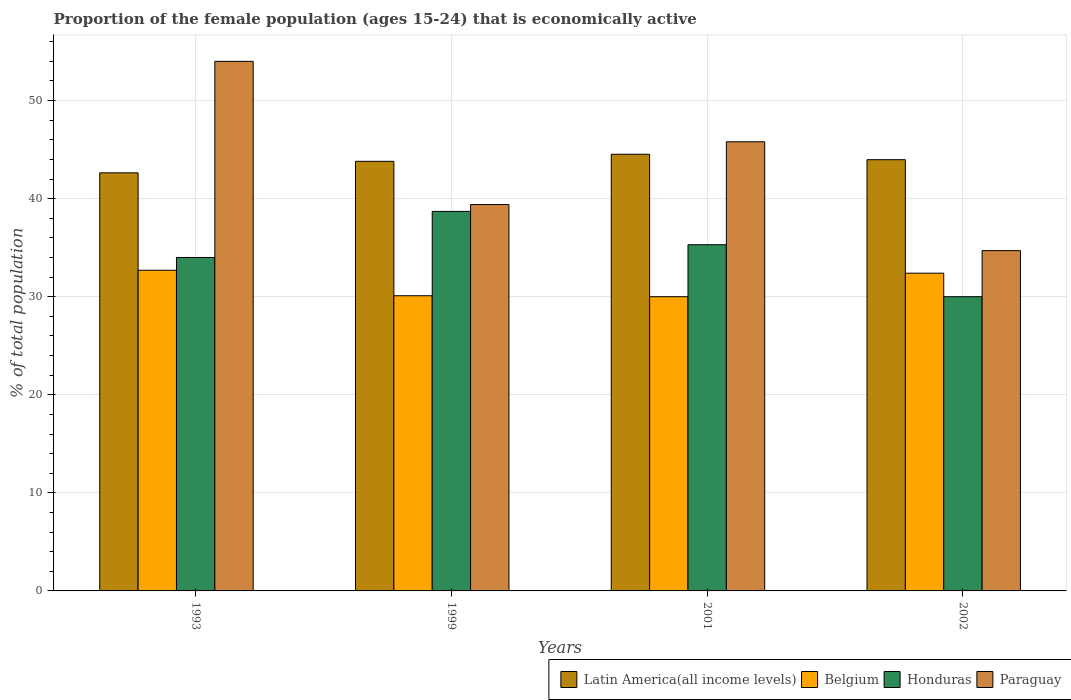How many groups of bars are there?
Your answer should be very brief. 4. Are the number of bars per tick equal to the number of legend labels?
Provide a short and direct response. Yes. Are the number of bars on each tick of the X-axis equal?
Your answer should be very brief. Yes. In how many cases, is the number of bars for a given year not equal to the number of legend labels?
Keep it short and to the point. 0. What is the proportion of the female population that is economically active in Belgium in 2001?
Offer a very short reply. 30. Across all years, what is the maximum proportion of the female population that is economically active in Belgium?
Provide a succinct answer. 32.7. Across all years, what is the minimum proportion of the female population that is economically active in Paraguay?
Make the answer very short. 34.7. In which year was the proportion of the female population that is economically active in Honduras maximum?
Ensure brevity in your answer.  1999. In which year was the proportion of the female population that is economically active in Belgium minimum?
Make the answer very short. 2001. What is the total proportion of the female population that is economically active in Belgium in the graph?
Your answer should be compact. 125.2. What is the difference between the proportion of the female population that is economically active in Belgium in 1999 and that in 2002?
Your response must be concise. -2.3. What is the difference between the proportion of the female population that is economically active in Honduras in 2002 and the proportion of the female population that is economically active in Paraguay in 1999?
Provide a succinct answer. -9.4. What is the average proportion of the female population that is economically active in Honduras per year?
Your response must be concise. 34.5. In the year 2002, what is the difference between the proportion of the female population that is economically active in Honduras and proportion of the female population that is economically active in Latin America(all income levels)?
Keep it short and to the point. -13.97. What is the ratio of the proportion of the female population that is economically active in Paraguay in 1993 to that in 2002?
Offer a very short reply. 1.56. Is the proportion of the female population that is economically active in Latin America(all income levels) in 1993 less than that in 2002?
Provide a succinct answer. Yes. Is the difference between the proportion of the female population that is economically active in Honduras in 1999 and 2001 greater than the difference between the proportion of the female population that is economically active in Latin America(all income levels) in 1999 and 2001?
Give a very brief answer. Yes. What is the difference between the highest and the second highest proportion of the female population that is economically active in Paraguay?
Offer a very short reply. 8.2. What is the difference between the highest and the lowest proportion of the female population that is economically active in Belgium?
Offer a very short reply. 2.7. In how many years, is the proportion of the female population that is economically active in Honduras greater than the average proportion of the female population that is economically active in Honduras taken over all years?
Keep it short and to the point. 2. Is the sum of the proportion of the female population that is economically active in Latin America(all income levels) in 1993 and 2001 greater than the maximum proportion of the female population that is economically active in Paraguay across all years?
Provide a short and direct response. Yes. What does the 4th bar from the left in 2002 represents?
Offer a terse response. Paraguay. What does the 1st bar from the right in 2001 represents?
Make the answer very short. Paraguay. Is it the case that in every year, the sum of the proportion of the female population that is economically active in Honduras and proportion of the female population that is economically active in Paraguay is greater than the proportion of the female population that is economically active in Latin America(all income levels)?
Offer a terse response. Yes. Are all the bars in the graph horizontal?
Your answer should be compact. No. How many years are there in the graph?
Ensure brevity in your answer.  4. What is the difference between two consecutive major ticks on the Y-axis?
Offer a very short reply. 10. Are the values on the major ticks of Y-axis written in scientific E-notation?
Provide a succinct answer. No. Does the graph contain any zero values?
Your response must be concise. No. Does the graph contain grids?
Your answer should be very brief. Yes. Where does the legend appear in the graph?
Offer a terse response. Bottom right. What is the title of the graph?
Your answer should be compact. Proportion of the female population (ages 15-24) that is economically active. Does "Serbia" appear as one of the legend labels in the graph?
Provide a short and direct response. No. What is the label or title of the Y-axis?
Provide a short and direct response. % of total population. What is the % of total population of Latin America(all income levels) in 1993?
Ensure brevity in your answer.  42.63. What is the % of total population of Belgium in 1993?
Offer a very short reply. 32.7. What is the % of total population of Honduras in 1993?
Ensure brevity in your answer.  34. What is the % of total population in Paraguay in 1993?
Provide a succinct answer. 54. What is the % of total population of Latin America(all income levels) in 1999?
Make the answer very short. 43.81. What is the % of total population in Belgium in 1999?
Your answer should be very brief. 30.1. What is the % of total population in Honduras in 1999?
Your response must be concise. 38.7. What is the % of total population in Paraguay in 1999?
Your answer should be very brief. 39.4. What is the % of total population of Latin America(all income levels) in 2001?
Provide a short and direct response. 44.53. What is the % of total population of Honduras in 2001?
Your answer should be very brief. 35.3. What is the % of total population of Paraguay in 2001?
Offer a very short reply. 45.8. What is the % of total population in Latin America(all income levels) in 2002?
Your answer should be very brief. 43.97. What is the % of total population in Belgium in 2002?
Your answer should be compact. 32.4. What is the % of total population in Paraguay in 2002?
Offer a very short reply. 34.7. Across all years, what is the maximum % of total population of Latin America(all income levels)?
Give a very brief answer. 44.53. Across all years, what is the maximum % of total population of Belgium?
Ensure brevity in your answer.  32.7. Across all years, what is the maximum % of total population in Honduras?
Ensure brevity in your answer.  38.7. Across all years, what is the minimum % of total population in Latin America(all income levels)?
Offer a terse response. 42.63. Across all years, what is the minimum % of total population in Belgium?
Your answer should be compact. 30. Across all years, what is the minimum % of total population in Paraguay?
Make the answer very short. 34.7. What is the total % of total population in Latin America(all income levels) in the graph?
Your answer should be very brief. 174.94. What is the total % of total population of Belgium in the graph?
Offer a very short reply. 125.2. What is the total % of total population in Honduras in the graph?
Offer a very short reply. 138. What is the total % of total population in Paraguay in the graph?
Give a very brief answer. 173.9. What is the difference between the % of total population of Latin America(all income levels) in 1993 and that in 1999?
Ensure brevity in your answer.  -1.17. What is the difference between the % of total population in Belgium in 1993 and that in 1999?
Offer a very short reply. 2.6. What is the difference between the % of total population of Honduras in 1993 and that in 1999?
Provide a succinct answer. -4.7. What is the difference between the % of total population of Paraguay in 1993 and that in 1999?
Keep it short and to the point. 14.6. What is the difference between the % of total population of Latin America(all income levels) in 1993 and that in 2001?
Your response must be concise. -1.9. What is the difference between the % of total population of Belgium in 1993 and that in 2001?
Provide a succinct answer. 2.7. What is the difference between the % of total population in Honduras in 1993 and that in 2001?
Keep it short and to the point. -1.3. What is the difference between the % of total population in Paraguay in 1993 and that in 2001?
Make the answer very short. 8.2. What is the difference between the % of total population in Latin America(all income levels) in 1993 and that in 2002?
Provide a succinct answer. -1.34. What is the difference between the % of total population of Paraguay in 1993 and that in 2002?
Keep it short and to the point. 19.3. What is the difference between the % of total population in Latin America(all income levels) in 1999 and that in 2001?
Provide a succinct answer. -0.72. What is the difference between the % of total population in Honduras in 1999 and that in 2001?
Provide a succinct answer. 3.4. What is the difference between the % of total population in Latin America(all income levels) in 1999 and that in 2002?
Ensure brevity in your answer.  -0.17. What is the difference between the % of total population in Honduras in 1999 and that in 2002?
Ensure brevity in your answer.  8.7. What is the difference between the % of total population of Paraguay in 1999 and that in 2002?
Provide a short and direct response. 4.7. What is the difference between the % of total population of Latin America(all income levels) in 2001 and that in 2002?
Provide a succinct answer. 0.56. What is the difference between the % of total population of Latin America(all income levels) in 1993 and the % of total population of Belgium in 1999?
Offer a very short reply. 12.53. What is the difference between the % of total population of Latin America(all income levels) in 1993 and the % of total population of Honduras in 1999?
Make the answer very short. 3.93. What is the difference between the % of total population in Latin America(all income levels) in 1993 and the % of total population in Paraguay in 1999?
Provide a short and direct response. 3.23. What is the difference between the % of total population in Belgium in 1993 and the % of total population in Honduras in 1999?
Offer a terse response. -6. What is the difference between the % of total population of Honduras in 1993 and the % of total population of Paraguay in 1999?
Offer a very short reply. -5.4. What is the difference between the % of total population in Latin America(all income levels) in 1993 and the % of total population in Belgium in 2001?
Offer a very short reply. 12.63. What is the difference between the % of total population in Latin America(all income levels) in 1993 and the % of total population in Honduras in 2001?
Your response must be concise. 7.33. What is the difference between the % of total population in Latin America(all income levels) in 1993 and the % of total population in Paraguay in 2001?
Your answer should be compact. -3.17. What is the difference between the % of total population in Belgium in 1993 and the % of total population in Paraguay in 2001?
Your response must be concise. -13.1. What is the difference between the % of total population in Latin America(all income levels) in 1993 and the % of total population in Belgium in 2002?
Provide a succinct answer. 10.23. What is the difference between the % of total population of Latin America(all income levels) in 1993 and the % of total population of Honduras in 2002?
Offer a terse response. 12.63. What is the difference between the % of total population of Latin America(all income levels) in 1993 and the % of total population of Paraguay in 2002?
Make the answer very short. 7.93. What is the difference between the % of total population of Belgium in 1993 and the % of total population of Paraguay in 2002?
Your response must be concise. -2. What is the difference between the % of total population in Latin America(all income levels) in 1999 and the % of total population in Belgium in 2001?
Offer a terse response. 13.81. What is the difference between the % of total population of Latin America(all income levels) in 1999 and the % of total population of Honduras in 2001?
Provide a succinct answer. 8.51. What is the difference between the % of total population in Latin America(all income levels) in 1999 and the % of total population in Paraguay in 2001?
Your response must be concise. -1.99. What is the difference between the % of total population in Belgium in 1999 and the % of total population in Paraguay in 2001?
Offer a very short reply. -15.7. What is the difference between the % of total population of Honduras in 1999 and the % of total population of Paraguay in 2001?
Your response must be concise. -7.1. What is the difference between the % of total population in Latin America(all income levels) in 1999 and the % of total population in Belgium in 2002?
Make the answer very short. 11.41. What is the difference between the % of total population in Latin America(all income levels) in 1999 and the % of total population in Honduras in 2002?
Offer a very short reply. 13.81. What is the difference between the % of total population in Latin America(all income levels) in 1999 and the % of total population in Paraguay in 2002?
Provide a succinct answer. 9.11. What is the difference between the % of total population in Belgium in 1999 and the % of total population in Honduras in 2002?
Provide a succinct answer. 0.1. What is the difference between the % of total population of Belgium in 1999 and the % of total population of Paraguay in 2002?
Provide a succinct answer. -4.6. What is the difference between the % of total population of Honduras in 1999 and the % of total population of Paraguay in 2002?
Give a very brief answer. 4. What is the difference between the % of total population of Latin America(all income levels) in 2001 and the % of total population of Belgium in 2002?
Provide a short and direct response. 12.13. What is the difference between the % of total population in Latin America(all income levels) in 2001 and the % of total population in Honduras in 2002?
Keep it short and to the point. 14.53. What is the difference between the % of total population in Latin America(all income levels) in 2001 and the % of total population in Paraguay in 2002?
Your answer should be very brief. 9.83. What is the difference between the % of total population in Belgium in 2001 and the % of total population in Paraguay in 2002?
Offer a very short reply. -4.7. What is the difference between the % of total population in Honduras in 2001 and the % of total population in Paraguay in 2002?
Ensure brevity in your answer.  0.6. What is the average % of total population of Latin America(all income levels) per year?
Keep it short and to the point. 43.73. What is the average % of total population in Belgium per year?
Your response must be concise. 31.3. What is the average % of total population of Honduras per year?
Your answer should be very brief. 34.5. What is the average % of total population in Paraguay per year?
Your answer should be very brief. 43.48. In the year 1993, what is the difference between the % of total population in Latin America(all income levels) and % of total population in Belgium?
Give a very brief answer. 9.93. In the year 1993, what is the difference between the % of total population of Latin America(all income levels) and % of total population of Honduras?
Provide a succinct answer. 8.63. In the year 1993, what is the difference between the % of total population in Latin America(all income levels) and % of total population in Paraguay?
Offer a very short reply. -11.37. In the year 1993, what is the difference between the % of total population in Belgium and % of total population in Paraguay?
Keep it short and to the point. -21.3. In the year 1993, what is the difference between the % of total population of Honduras and % of total population of Paraguay?
Offer a very short reply. -20. In the year 1999, what is the difference between the % of total population of Latin America(all income levels) and % of total population of Belgium?
Ensure brevity in your answer.  13.71. In the year 1999, what is the difference between the % of total population of Latin America(all income levels) and % of total population of Honduras?
Your answer should be very brief. 5.11. In the year 1999, what is the difference between the % of total population of Latin America(all income levels) and % of total population of Paraguay?
Provide a succinct answer. 4.41. In the year 1999, what is the difference between the % of total population in Belgium and % of total population in Honduras?
Make the answer very short. -8.6. In the year 1999, what is the difference between the % of total population of Honduras and % of total population of Paraguay?
Your answer should be very brief. -0.7. In the year 2001, what is the difference between the % of total population in Latin America(all income levels) and % of total population in Belgium?
Make the answer very short. 14.53. In the year 2001, what is the difference between the % of total population in Latin America(all income levels) and % of total population in Honduras?
Ensure brevity in your answer.  9.23. In the year 2001, what is the difference between the % of total population in Latin America(all income levels) and % of total population in Paraguay?
Give a very brief answer. -1.27. In the year 2001, what is the difference between the % of total population in Belgium and % of total population in Paraguay?
Your response must be concise. -15.8. In the year 2002, what is the difference between the % of total population of Latin America(all income levels) and % of total population of Belgium?
Your answer should be very brief. 11.57. In the year 2002, what is the difference between the % of total population of Latin America(all income levels) and % of total population of Honduras?
Ensure brevity in your answer.  13.97. In the year 2002, what is the difference between the % of total population of Latin America(all income levels) and % of total population of Paraguay?
Give a very brief answer. 9.27. In the year 2002, what is the difference between the % of total population in Belgium and % of total population in Honduras?
Provide a short and direct response. 2.4. In the year 2002, what is the difference between the % of total population of Belgium and % of total population of Paraguay?
Keep it short and to the point. -2.3. In the year 2002, what is the difference between the % of total population in Honduras and % of total population in Paraguay?
Provide a short and direct response. -4.7. What is the ratio of the % of total population in Latin America(all income levels) in 1993 to that in 1999?
Your answer should be compact. 0.97. What is the ratio of the % of total population of Belgium in 1993 to that in 1999?
Ensure brevity in your answer.  1.09. What is the ratio of the % of total population in Honduras in 1993 to that in 1999?
Provide a short and direct response. 0.88. What is the ratio of the % of total population of Paraguay in 1993 to that in 1999?
Your answer should be very brief. 1.37. What is the ratio of the % of total population in Latin America(all income levels) in 1993 to that in 2001?
Provide a succinct answer. 0.96. What is the ratio of the % of total population of Belgium in 1993 to that in 2001?
Provide a short and direct response. 1.09. What is the ratio of the % of total population in Honduras in 1993 to that in 2001?
Your response must be concise. 0.96. What is the ratio of the % of total population in Paraguay in 1993 to that in 2001?
Your response must be concise. 1.18. What is the ratio of the % of total population of Latin America(all income levels) in 1993 to that in 2002?
Offer a very short reply. 0.97. What is the ratio of the % of total population in Belgium in 1993 to that in 2002?
Keep it short and to the point. 1.01. What is the ratio of the % of total population in Honduras in 1993 to that in 2002?
Your response must be concise. 1.13. What is the ratio of the % of total population of Paraguay in 1993 to that in 2002?
Offer a terse response. 1.56. What is the ratio of the % of total population in Latin America(all income levels) in 1999 to that in 2001?
Give a very brief answer. 0.98. What is the ratio of the % of total population in Honduras in 1999 to that in 2001?
Your answer should be very brief. 1.1. What is the ratio of the % of total population of Paraguay in 1999 to that in 2001?
Give a very brief answer. 0.86. What is the ratio of the % of total population of Latin America(all income levels) in 1999 to that in 2002?
Offer a terse response. 1. What is the ratio of the % of total population of Belgium in 1999 to that in 2002?
Offer a very short reply. 0.93. What is the ratio of the % of total population in Honduras in 1999 to that in 2002?
Ensure brevity in your answer.  1.29. What is the ratio of the % of total population in Paraguay in 1999 to that in 2002?
Ensure brevity in your answer.  1.14. What is the ratio of the % of total population in Latin America(all income levels) in 2001 to that in 2002?
Provide a short and direct response. 1.01. What is the ratio of the % of total population in Belgium in 2001 to that in 2002?
Your response must be concise. 0.93. What is the ratio of the % of total population in Honduras in 2001 to that in 2002?
Ensure brevity in your answer.  1.18. What is the ratio of the % of total population in Paraguay in 2001 to that in 2002?
Provide a short and direct response. 1.32. What is the difference between the highest and the second highest % of total population of Latin America(all income levels)?
Offer a terse response. 0.56. What is the difference between the highest and the second highest % of total population in Honduras?
Provide a short and direct response. 3.4. What is the difference between the highest and the lowest % of total population of Latin America(all income levels)?
Your answer should be compact. 1.9. What is the difference between the highest and the lowest % of total population of Paraguay?
Ensure brevity in your answer.  19.3. 